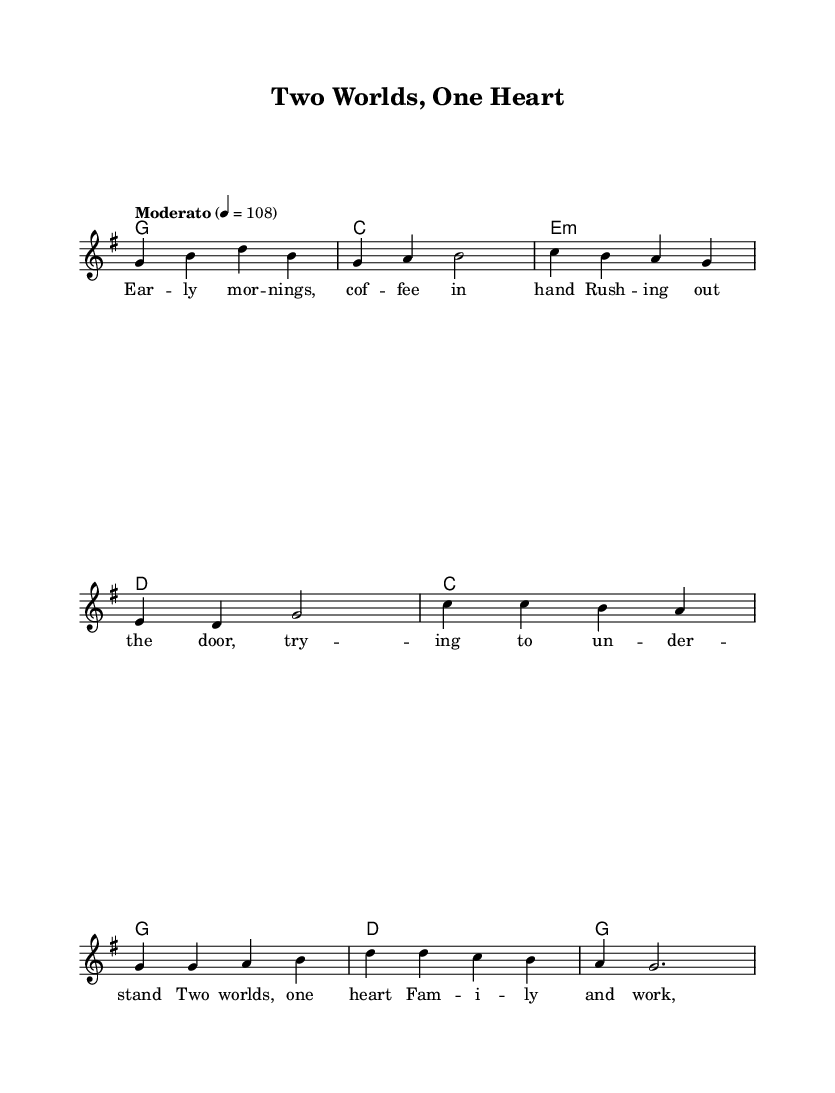What is the key signature of this music? The key signature is G major, which has one sharp (F#). You can determine the key signature by looking at the indication after the \key command in the global section.
Answer: G major What is the time signature of this music? The time signature is 4/4, which indicates four beats per measure and a quarter note gets one beat. This is specified after the \time command in the global section.
Answer: 4/4 What is the tempo marking indicated in the sheet music? The tempo marking is Moderato, which generally means a moderate speed. The tempo is quantified as 4 = 108 in beats per minute, found in the global section.
Answer: Moderato How many measures are in the verse section? There are four measures in the verse section, as one can count the groups of syllables corresponding to the melody and lyrics following the verse in the provided music.
Answer: 4 In the chorus, how many distinct chords are used? There are four distinct chords used in the chorus section: C, G, D, and G again. These occur sequentially as specified in the chorusChords section.
Answer: 4 What theme is reflected in the lyrics of this song? The theme of balancing work and family life is reflected in the lyrics, which mention early mornings, family, and work being never far apart. This theme is common in country music, reflecting everyday life.
Answer: Balancing work and family life What is the relationship between the melody and the chords? The melody corresponds to specific chords through its notes, where each chord supports the melody during the verse and chorus sections. This is evident as the melody notes are aligned specifically under the chord symbols in the score.
Answer: Chords support the melody 